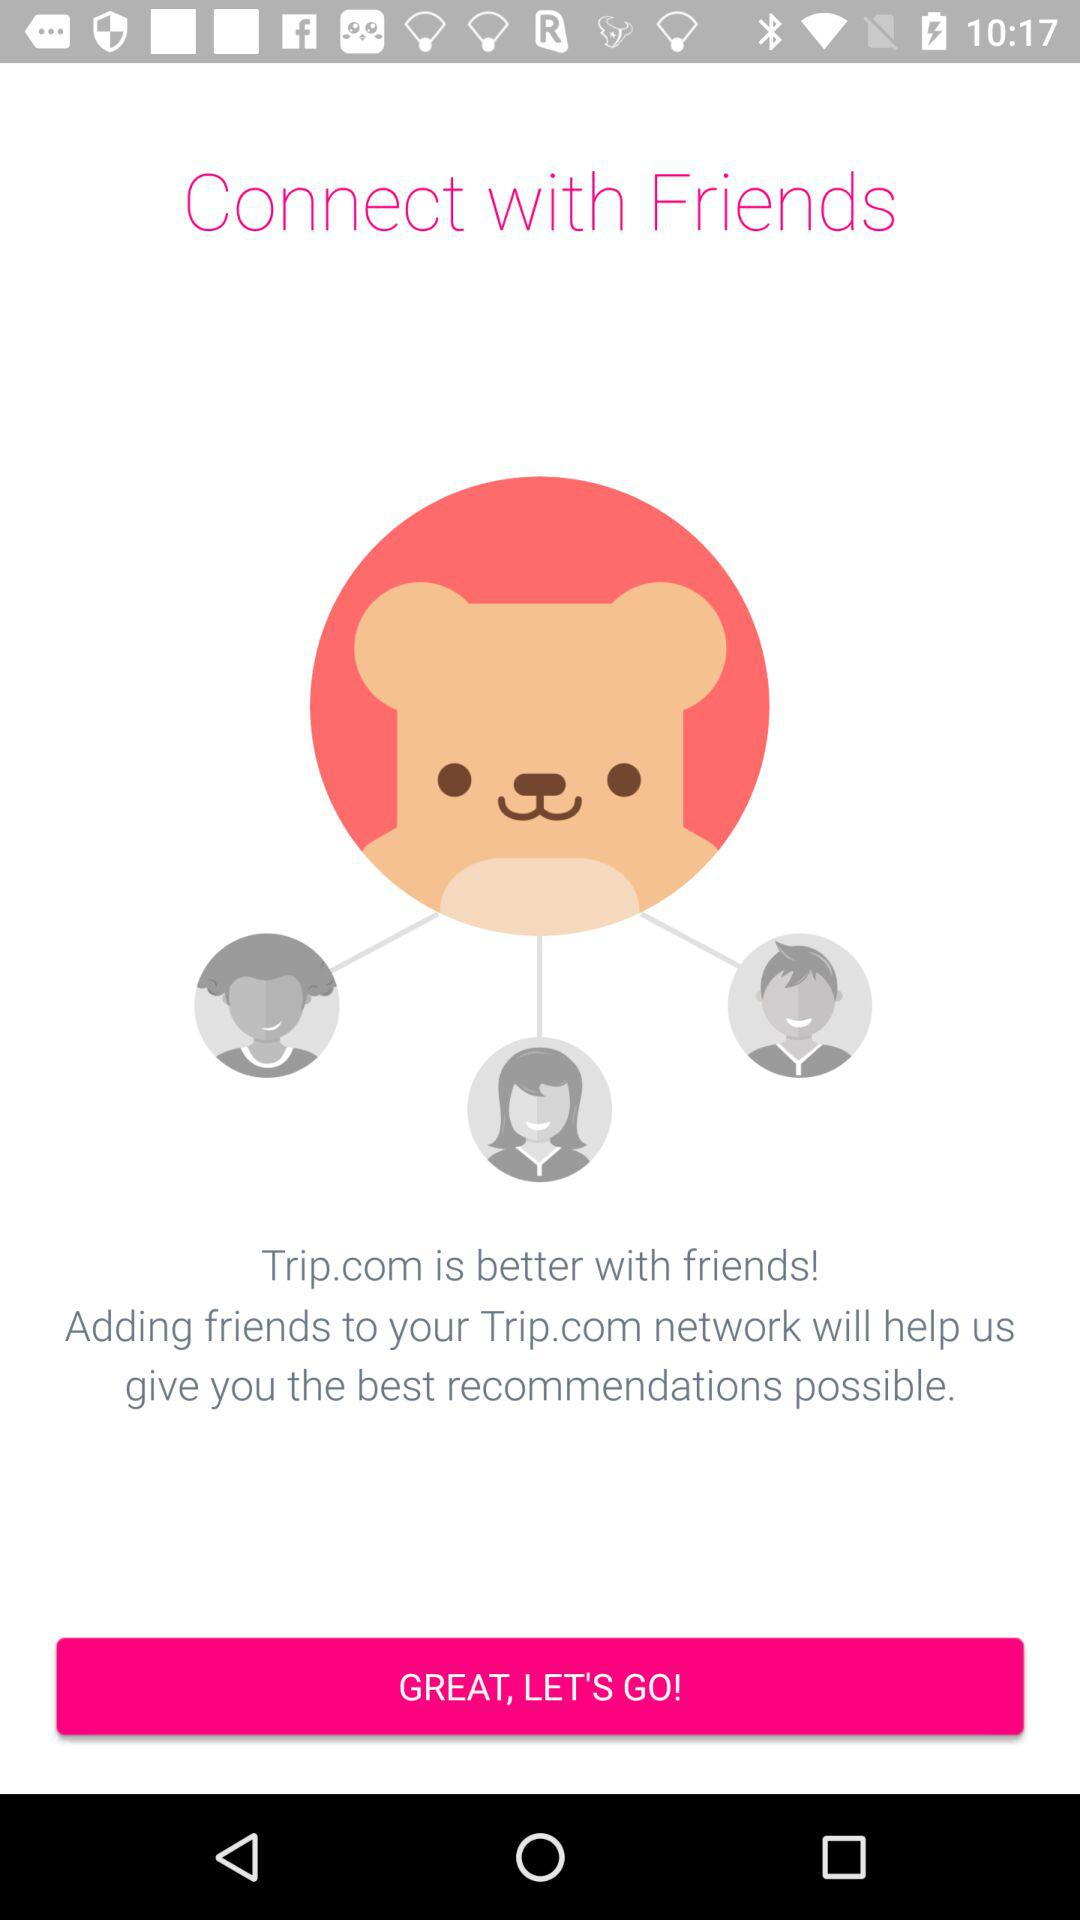What is the application name? The application name is "Trip.com". 